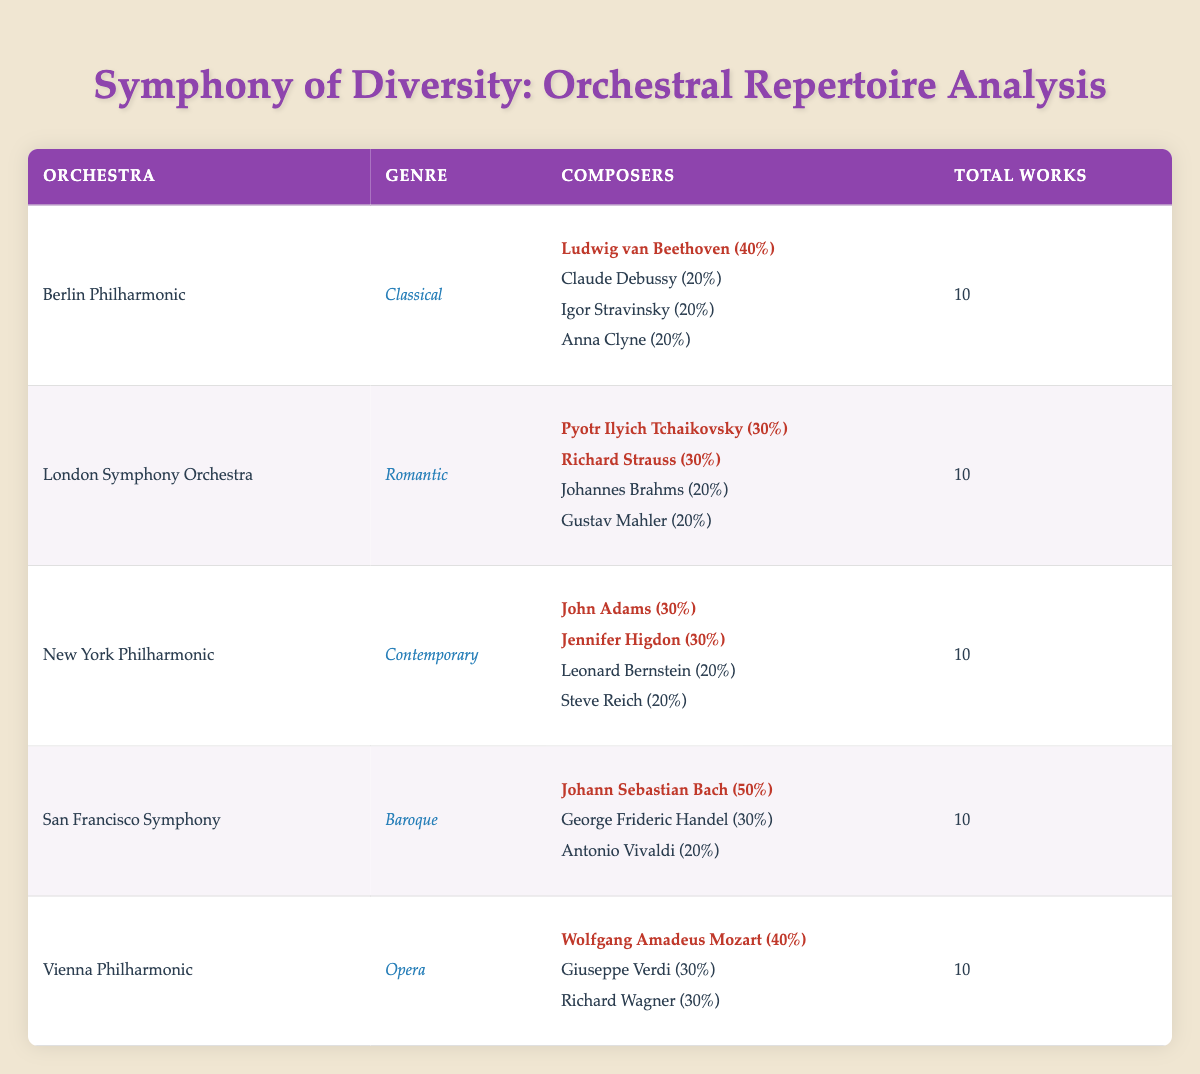What is the total number of works performed by the San Francisco Symphony? The table specifies that the total works performed by the San Francisco Symphony is listed as 10 in the corresponding row.
Answer: 10 Which composer had the highest representation in works performed by the Berlin Philharmonic? Ludwig van Beethoven is highlighted as having 40% representation of the works performed, making him the highest represented composer for that orchestra.
Answer: Ludwig van Beethoven How many composers are represented in the New York Philharmonic's performance? The table indicates that the New York Philharmonic has 4 composers listed, each with their respective works performed and percentages.
Answer: 4 Which genre has the highest percentage representation for a single composer and who is that composer? The Baroque genre has Johann Sebastian Bach with a representation of 50%, which is the highest representation among all genres and composers.
Answer: Johann Sebastian Bach True or False: The Vienna Philharmonic performed more works by Richard Wagner than by Giuseppe Verdi. The table shows that Richard Wagner and Giuseppe Verdi both had 3 and 4 works performed, respectively, with Verdi having more. Thus, the statement is false.
Answer: False What is the combined percentage representation of composers in the Romantic genre? The Romantic genre has Pyotr Ilyich Tchaikovsky (30%), Johannes Brahms (20%), Richard Strauss (30%), and Gustav Mahler (20%). Adding these percentages gives 30 + 20 + 30 + 20 = 100%.
Answer: 100% Which orchestra has the least diverse representation based on the percentage of works performed by individual composers? To determine this, we can compare the highest percentages in each orchestra. The highest representation for the San Francisco Symphony is 50% (Bach), while others have lower representations. This suggests San Francisco Symphony has the least diversity.
Answer: San Francisco Symphony What is the average percentage representation of composers in the Contemporary genre? The percentages for the composers in the Contemporary genre are John Adams (30%), Jennifer Higdon (30%), Leonard Bernstein (20%), and Steve Reich (20%). To find the average, sum these percentages (30 + 30 + 20 + 20 = 100) and divide by 4, resulting in an average of 100/4 = 25%.
Answer: 25% 